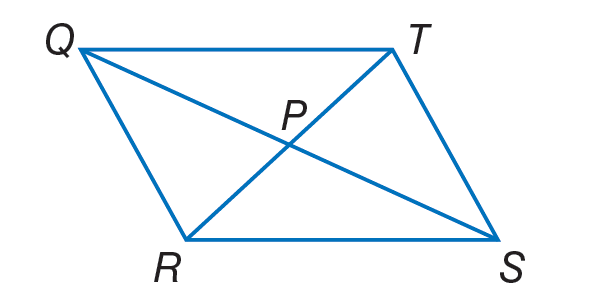Answer the mathemtical geometry problem and directly provide the correct option letter.
Question: If T P = 4 x + 2, Q P = 2 y - 6, P S = 5 y - 12, and P R = 6 x - 4, find y so that the quadrilateral is a parallelogram.
Choices: A: 2 B: 5 C: 12 D: 20 A 